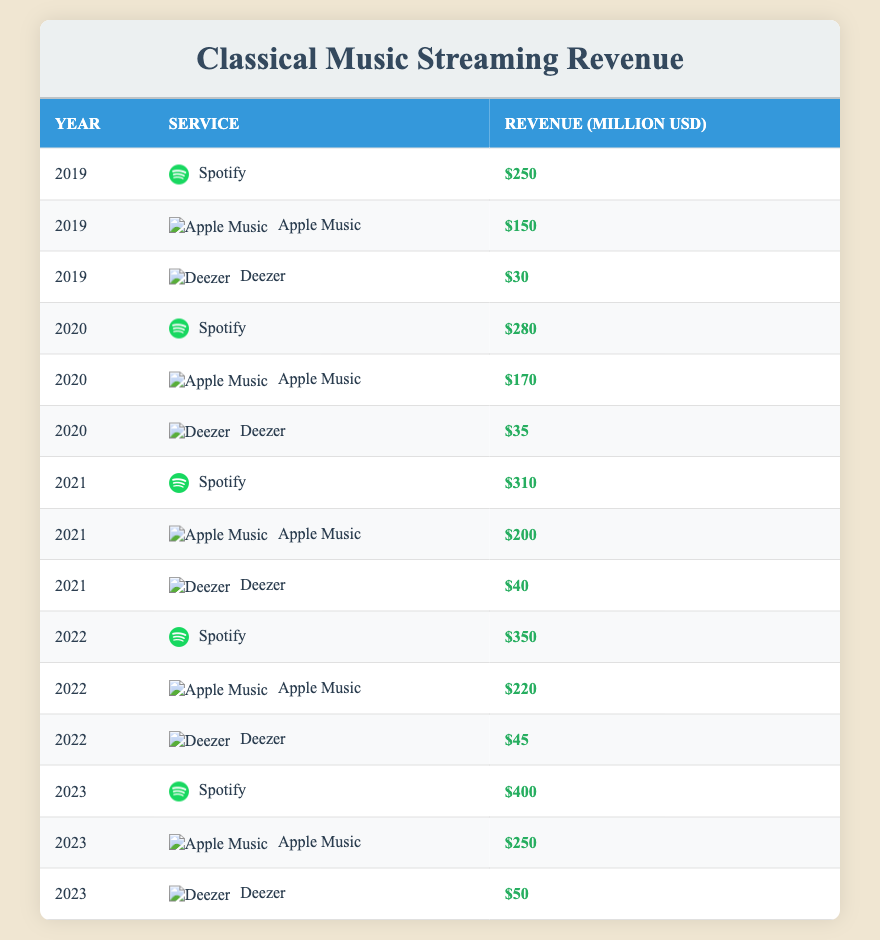What was the revenue generated by Spotify in 2021? From the table, locate the row corresponding to the year 2021 and the service Spotify. The revenue for Spotify in 2021 is listed as 310 million USD.
Answer: 310 million USD In which year did Apple Music generate the highest revenue? By examining the relevant rows for Apple Music, we find the revenues for each year: 150 (2019), 170 (2020), 200 (2021), 220 (2022), and 250 (2023). The highest revenue is in 2023, which is 250 million USD.
Answer: 2023 What is the total revenue generated by Deezer over the years 2019 to 2023? To find the total revenue for Deezer, sum the revenues for each year: 30 (2019) + 35 (2020) + 40 (2021) + 45 (2022) + 50 (2023) = 200 million USD.
Answer: 200 million USD Did the revenue for classical music streaming services increase every year from 2019 to 2023? Checking the revenues listed year by year, we see that they are: 250 (2019), 280 (2020), 310 (2021), 350 (2022), and 400 (2023). Since all values are increasing from year to year, the answer is yes.
Answer: Yes What is the average revenue generated by Spotify from 2019 to 2023? First, add the revenues: 250 (2019) + 280 (2020) + 310 (2021) + 350 (2022) + 400 (2023) = 1590 million USD. Then, divide by the number of years (5). Thus, the average revenue is 1590 / 5 = 318 million USD.
Answer: 318 million USD How much more revenue did Apple Music generate in 2023 compared to 2021? For Apple Music, the revenues in 2023 and 2021 are 250 million USD and 200 million USD, respectively. To find the difference, subtract 200 from 250, which gives us 50 million USD.
Answer: 50 million USD Which service had the least revenue in 2022? In 2022, the revenues were: Spotify 350 million USD, Apple Music 220 million USD, and Deezer 45 million USD. Therefore, Deezer had the lowest revenue among these services.
Answer: Deezer What was the revenue growth of Spotify from 2019 to 2023? Identify the revenue for Spotify in 2019 (250 million USD) and 2023 (400 million USD). The growth is calculated as 400 - 250, resulting in an increase of 150 million USD.
Answer: 150 million USD Was Deezer the only service to generate less than 50 million USD in revenue in 2019? Checking the revenue for Deezer in 2019 (30 million USD) and comparing it with Spotify (250 million USD) and Apple Music (150 million USD), we find that both other services generated more than 50 million USD, confirming Deezer is the only one under that mark.
Answer: Yes What was the percentage increase in revenue for Apple Music from 2020 to 2021? For Apple Music, the revenue increased from 170 million USD in 2020 to 200 million USD in 2021. The percentage increase is calculated by (200 - 170) / 170 * 100, which is approximately 17.65%.
Answer: Approximately 17.65% 